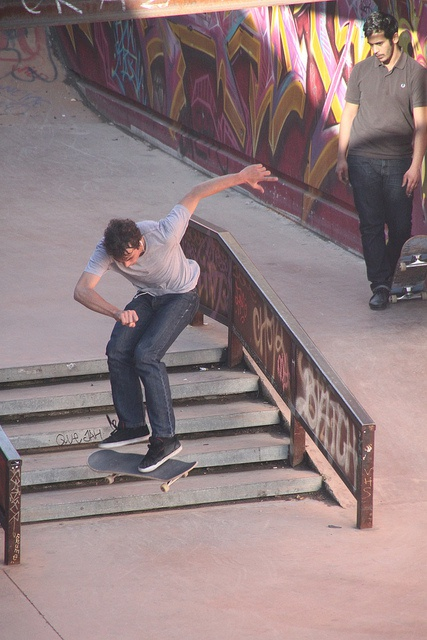Describe the objects in this image and their specific colors. I can see people in black, gray, and darkgray tones, people in black and gray tones, skateboard in black, gray, and darkgray tones, and skateboard in black, gray, and darkgray tones in this image. 